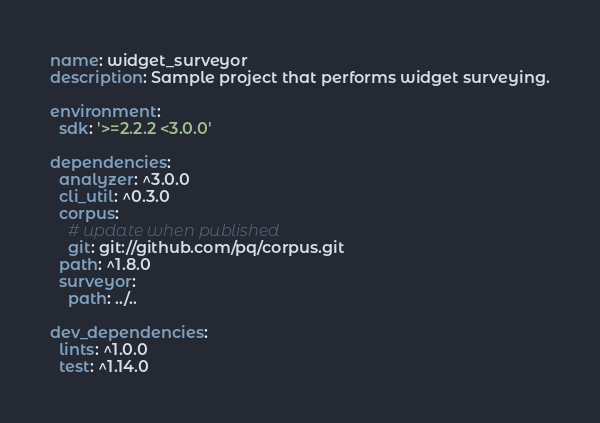Convert code to text. <code><loc_0><loc_0><loc_500><loc_500><_YAML_>name: widget_surveyor
description: Sample project that performs widget surveying.

environment:
  sdk: '>=2.2.2 <3.0.0'

dependencies:
  analyzer: ^3.0.0
  cli_util: ^0.3.0
  corpus:
    # update when published
    git: git://github.com/pq/corpus.git
  path: ^1.8.0
  surveyor:
    path: ../..

dev_dependencies:
  lints: ^1.0.0
  test: ^1.14.0
</code> 